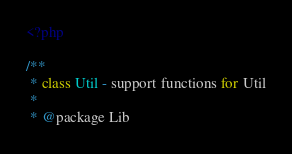<code> <loc_0><loc_0><loc_500><loc_500><_PHP_><?php

/**
 * class Util - support functions for Util
 *
 * @package Lib</code> 